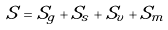<formula> <loc_0><loc_0><loc_500><loc_500>S = S _ { g } + S _ { s } + S _ { v } + S _ { m }</formula> 